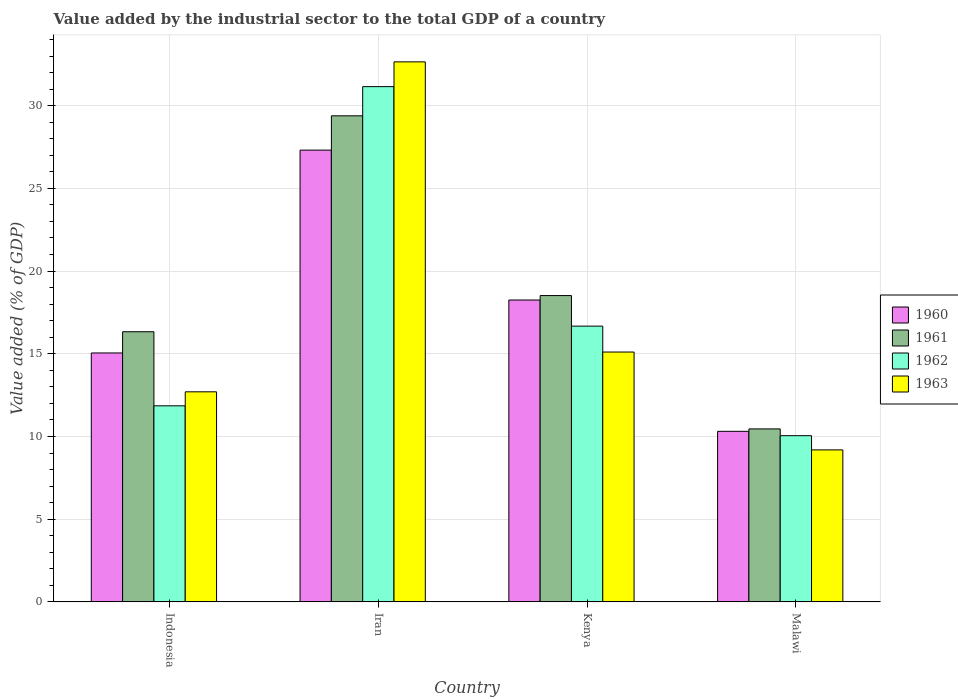Are the number of bars per tick equal to the number of legend labels?
Your response must be concise. Yes. Are the number of bars on each tick of the X-axis equal?
Your response must be concise. Yes. How many bars are there on the 2nd tick from the right?
Ensure brevity in your answer.  4. In how many cases, is the number of bars for a given country not equal to the number of legend labels?
Your answer should be very brief. 0. What is the value added by the industrial sector to the total GDP in 1960 in Indonesia?
Keep it short and to the point. 15.05. Across all countries, what is the maximum value added by the industrial sector to the total GDP in 1962?
Ensure brevity in your answer.  31.15. Across all countries, what is the minimum value added by the industrial sector to the total GDP in 1961?
Make the answer very short. 10.46. In which country was the value added by the industrial sector to the total GDP in 1962 maximum?
Give a very brief answer. Iran. In which country was the value added by the industrial sector to the total GDP in 1963 minimum?
Provide a succinct answer. Malawi. What is the total value added by the industrial sector to the total GDP in 1963 in the graph?
Give a very brief answer. 69.64. What is the difference between the value added by the industrial sector to the total GDP in 1963 in Iran and that in Malawi?
Give a very brief answer. 23.46. What is the difference between the value added by the industrial sector to the total GDP in 1962 in Kenya and the value added by the industrial sector to the total GDP in 1961 in Iran?
Offer a very short reply. -12.71. What is the average value added by the industrial sector to the total GDP in 1962 per country?
Your response must be concise. 17.43. What is the difference between the value added by the industrial sector to the total GDP of/in 1962 and value added by the industrial sector to the total GDP of/in 1960 in Iran?
Offer a very short reply. 3.84. In how many countries, is the value added by the industrial sector to the total GDP in 1960 greater than 8 %?
Make the answer very short. 4. What is the ratio of the value added by the industrial sector to the total GDP in 1961 in Iran to that in Malawi?
Offer a very short reply. 2.81. Is the difference between the value added by the industrial sector to the total GDP in 1962 in Kenya and Malawi greater than the difference between the value added by the industrial sector to the total GDP in 1960 in Kenya and Malawi?
Ensure brevity in your answer.  No. What is the difference between the highest and the second highest value added by the industrial sector to the total GDP in 1962?
Offer a very short reply. 4.82. What is the difference between the highest and the lowest value added by the industrial sector to the total GDP in 1961?
Give a very brief answer. 18.93. In how many countries, is the value added by the industrial sector to the total GDP in 1962 greater than the average value added by the industrial sector to the total GDP in 1962 taken over all countries?
Offer a terse response. 1. What does the 1st bar from the left in Iran represents?
Your answer should be compact. 1960. What does the 4th bar from the right in Indonesia represents?
Ensure brevity in your answer.  1960. Is it the case that in every country, the sum of the value added by the industrial sector to the total GDP in 1961 and value added by the industrial sector to the total GDP in 1962 is greater than the value added by the industrial sector to the total GDP in 1963?
Your answer should be very brief. Yes. How many bars are there?
Your response must be concise. 16. How many countries are there in the graph?
Provide a short and direct response. 4. Are the values on the major ticks of Y-axis written in scientific E-notation?
Offer a very short reply. No. Does the graph contain any zero values?
Offer a terse response. No. Where does the legend appear in the graph?
Offer a very short reply. Center right. How many legend labels are there?
Ensure brevity in your answer.  4. What is the title of the graph?
Your answer should be compact. Value added by the industrial sector to the total GDP of a country. Does "1981" appear as one of the legend labels in the graph?
Provide a short and direct response. No. What is the label or title of the Y-axis?
Your answer should be compact. Value added (% of GDP). What is the Value added (% of GDP) in 1960 in Indonesia?
Keep it short and to the point. 15.05. What is the Value added (% of GDP) in 1961 in Indonesia?
Give a very brief answer. 16.33. What is the Value added (% of GDP) of 1962 in Indonesia?
Your answer should be compact. 11.85. What is the Value added (% of GDP) in 1963 in Indonesia?
Keep it short and to the point. 12.7. What is the Value added (% of GDP) of 1960 in Iran?
Keep it short and to the point. 27.31. What is the Value added (% of GDP) in 1961 in Iran?
Ensure brevity in your answer.  29.38. What is the Value added (% of GDP) in 1962 in Iran?
Provide a succinct answer. 31.15. What is the Value added (% of GDP) of 1963 in Iran?
Keep it short and to the point. 32.65. What is the Value added (% of GDP) of 1960 in Kenya?
Offer a terse response. 18.25. What is the Value added (% of GDP) of 1961 in Kenya?
Make the answer very short. 18.52. What is the Value added (% of GDP) of 1962 in Kenya?
Your response must be concise. 16.67. What is the Value added (% of GDP) of 1963 in Kenya?
Provide a short and direct response. 15.1. What is the Value added (% of GDP) of 1960 in Malawi?
Offer a terse response. 10.31. What is the Value added (% of GDP) in 1961 in Malawi?
Make the answer very short. 10.46. What is the Value added (% of GDP) in 1962 in Malawi?
Provide a short and direct response. 10.05. What is the Value added (% of GDP) of 1963 in Malawi?
Provide a short and direct response. 9.19. Across all countries, what is the maximum Value added (% of GDP) in 1960?
Ensure brevity in your answer.  27.31. Across all countries, what is the maximum Value added (% of GDP) in 1961?
Your answer should be compact. 29.38. Across all countries, what is the maximum Value added (% of GDP) of 1962?
Give a very brief answer. 31.15. Across all countries, what is the maximum Value added (% of GDP) in 1963?
Make the answer very short. 32.65. Across all countries, what is the minimum Value added (% of GDP) of 1960?
Provide a succinct answer. 10.31. Across all countries, what is the minimum Value added (% of GDP) in 1961?
Make the answer very short. 10.46. Across all countries, what is the minimum Value added (% of GDP) of 1962?
Provide a succinct answer. 10.05. Across all countries, what is the minimum Value added (% of GDP) in 1963?
Keep it short and to the point. 9.19. What is the total Value added (% of GDP) of 1960 in the graph?
Ensure brevity in your answer.  70.92. What is the total Value added (% of GDP) of 1961 in the graph?
Your answer should be very brief. 74.69. What is the total Value added (% of GDP) in 1962 in the graph?
Your response must be concise. 69.72. What is the total Value added (% of GDP) of 1963 in the graph?
Offer a very short reply. 69.64. What is the difference between the Value added (% of GDP) in 1960 in Indonesia and that in Iran?
Keep it short and to the point. -12.26. What is the difference between the Value added (% of GDP) in 1961 in Indonesia and that in Iran?
Offer a terse response. -13.05. What is the difference between the Value added (% of GDP) of 1962 in Indonesia and that in Iran?
Ensure brevity in your answer.  -19.3. What is the difference between the Value added (% of GDP) of 1963 in Indonesia and that in Iran?
Ensure brevity in your answer.  -19.95. What is the difference between the Value added (% of GDP) in 1960 in Indonesia and that in Kenya?
Your answer should be compact. -3.2. What is the difference between the Value added (% of GDP) in 1961 in Indonesia and that in Kenya?
Your response must be concise. -2.19. What is the difference between the Value added (% of GDP) in 1962 in Indonesia and that in Kenya?
Your answer should be compact. -4.82. What is the difference between the Value added (% of GDP) in 1963 in Indonesia and that in Kenya?
Your answer should be compact. -2.4. What is the difference between the Value added (% of GDP) of 1960 in Indonesia and that in Malawi?
Offer a terse response. 4.74. What is the difference between the Value added (% of GDP) in 1961 in Indonesia and that in Malawi?
Make the answer very short. 5.87. What is the difference between the Value added (% of GDP) of 1962 in Indonesia and that in Malawi?
Your answer should be very brief. 1.8. What is the difference between the Value added (% of GDP) in 1963 in Indonesia and that in Malawi?
Your answer should be very brief. 3.51. What is the difference between the Value added (% of GDP) in 1960 in Iran and that in Kenya?
Keep it short and to the point. 9.06. What is the difference between the Value added (% of GDP) in 1961 in Iran and that in Kenya?
Provide a short and direct response. 10.87. What is the difference between the Value added (% of GDP) of 1962 in Iran and that in Kenya?
Give a very brief answer. 14.48. What is the difference between the Value added (% of GDP) of 1963 in Iran and that in Kenya?
Your answer should be very brief. 17.54. What is the difference between the Value added (% of GDP) in 1960 in Iran and that in Malawi?
Provide a short and direct response. 17. What is the difference between the Value added (% of GDP) of 1961 in Iran and that in Malawi?
Provide a succinct answer. 18.93. What is the difference between the Value added (% of GDP) in 1962 in Iran and that in Malawi?
Provide a succinct answer. 21.1. What is the difference between the Value added (% of GDP) of 1963 in Iran and that in Malawi?
Your answer should be very brief. 23.46. What is the difference between the Value added (% of GDP) in 1960 in Kenya and that in Malawi?
Provide a succinct answer. 7.94. What is the difference between the Value added (% of GDP) in 1961 in Kenya and that in Malawi?
Provide a succinct answer. 8.06. What is the difference between the Value added (% of GDP) of 1962 in Kenya and that in Malawi?
Offer a very short reply. 6.62. What is the difference between the Value added (% of GDP) of 1963 in Kenya and that in Malawi?
Offer a terse response. 5.92. What is the difference between the Value added (% of GDP) of 1960 in Indonesia and the Value added (% of GDP) of 1961 in Iran?
Your response must be concise. -14.34. What is the difference between the Value added (% of GDP) of 1960 in Indonesia and the Value added (% of GDP) of 1962 in Iran?
Ensure brevity in your answer.  -16.1. What is the difference between the Value added (% of GDP) in 1960 in Indonesia and the Value added (% of GDP) in 1963 in Iran?
Give a very brief answer. -17.6. What is the difference between the Value added (% of GDP) of 1961 in Indonesia and the Value added (% of GDP) of 1962 in Iran?
Make the answer very short. -14.82. What is the difference between the Value added (% of GDP) of 1961 in Indonesia and the Value added (% of GDP) of 1963 in Iran?
Your response must be concise. -16.32. What is the difference between the Value added (% of GDP) in 1962 in Indonesia and the Value added (% of GDP) in 1963 in Iran?
Make the answer very short. -20.79. What is the difference between the Value added (% of GDP) in 1960 in Indonesia and the Value added (% of GDP) in 1961 in Kenya?
Provide a short and direct response. -3.47. What is the difference between the Value added (% of GDP) in 1960 in Indonesia and the Value added (% of GDP) in 1962 in Kenya?
Provide a succinct answer. -1.62. What is the difference between the Value added (% of GDP) of 1960 in Indonesia and the Value added (% of GDP) of 1963 in Kenya?
Your answer should be very brief. -0.06. What is the difference between the Value added (% of GDP) of 1961 in Indonesia and the Value added (% of GDP) of 1962 in Kenya?
Provide a short and direct response. -0.34. What is the difference between the Value added (% of GDP) of 1961 in Indonesia and the Value added (% of GDP) of 1963 in Kenya?
Keep it short and to the point. 1.23. What is the difference between the Value added (% of GDP) of 1962 in Indonesia and the Value added (% of GDP) of 1963 in Kenya?
Your answer should be very brief. -3.25. What is the difference between the Value added (% of GDP) of 1960 in Indonesia and the Value added (% of GDP) of 1961 in Malawi?
Offer a terse response. 4.59. What is the difference between the Value added (% of GDP) in 1960 in Indonesia and the Value added (% of GDP) in 1962 in Malawi?
Give a very brief answer. 5. What is the difference between the Value added (% of GDP) in 1960 in Indonesia and the Value added (% of GDP) in 1963 in Malawi?
Your answer should be compact. 5.86. What is the difference between the Value added (% of GDP) of 1961 in Indonesia and the Value added (% of GDP) of 1962 in Malawi?
Offer a very short reply. 6.28. What is the difference between the Value added (% of GDP) of 1961 in Indonesia and the Value added (% of GDP) of 1963 in Malawi?
Offer a terse response. 7.14. What is the difference between the Value added (% of GDP) of 1962 in Indonesia and the Value added (% of GDP) of 1963 in Malawi?
Your answer should be compact. 2.66. What is the difference between the Value added (% of GDP) of 1960 in Iran and the Value added (% of GDP) of 1961 in Kenya?
Give a very brief answer. 8.79. What is the difference between the Value added (% of GDP) in 1960 in Iran and the Value added (% of GDP) in 1962 in Kenya?
Your answer should be compact. 10.64. What is the difference between the Value added (% of GDP) of 1960 in Iran and the Value added (% of GDP) of 1963 in Kenya?
Ensure brevity in your answer.  12.21. What is the difference between the Value added (% of GDP) in 1961 in Iran and the Value added (% of GDP) in 1962 in Kenya?
Give a very brief answer. 12.71. What is the difference between the Value added (% of GDP) of 1961 in Iran and the Value added (% of GDP) of 1963 in Kenya?
Provide a succinct answer. 14.28. What is the difference between the Value added (% of GDP) of 1962 in Iran and the Value added (% of GDP) of 1963 in Kenya?
Keep it short and to the point. 16.04. What is the difference between the Value added (% of GDP) of 1960 in Iran and the Value added (% of GDP) of 1961 in Malawi?
Your answer should be compact. 16.86. What is the difference between the Value added (% of GDP) of 1960 in Iran and the Value added (% of GDP) of 1962 in Malawi?
Make the answer very short. 17.26. What is the difference between the Value added (% of GDP) in 1960 in Iran and the Value added (% of GDP) in 1963 in Malawi?
Your answer should be compact. 18.12. What is the difference between the Value added (% of GDP) of 1961 in Iran and the Value added (% of GDP) of 1962 in Malawi?
Offer a very short reply. 19.34. What is the difference between the Value added (% of GDP) of 1961 in Iran and the Value added (% of GDP) of 1963 in Malawi?
Give a very brief answer. 20.2. What is the difference between the Value added (% of GDP) in 1962 in Iran and the Value added (% of GDP) in 1963 in Malawi?
Your answer should be very brief. 21.96. What is the difference between the Value added (% of GDP) of 1960 in Kenya and the Value added (% of GDP) of 1961 in Malawi?
Keep it short and to the point. 7.79. What is the difference between the Value added (% of GDP) of 1960 in Kenya and the Value added (% of GDP) of 1962 in Malawi?
Provide a short and direct response. 8.2. What is the difference between the Value added (% of GDP) in 1960 in Kenya and the Value added (% of GDP) in 1963 in Malawi?
Your response must be concise. 9.06. What is the difference between the Value added (% of GDP) in 1961 in Kenya and the Value added (% of GDP) in 1962 in Malawi?
Provide a succinct answer. 8.47. What is the difference between the Value added (% of GDP) in 1961 in Kenya and the Value added (% of GDP) in 1963 in Malawi?
Your answer should be compact. 9.33. What is the difference between the Value added (% of GDP) in 1962 in Kenya and the Value added (% of GDP) in 1963 in Malawi?
Keep it short and to the point. 7.48. What is the average Value added (% of GDP) of 1960 per country?
Your response must be concise. 17.73. What is the average Value added (% of GDP) in 1961 per country?
Ensure brevity in your answer.  18.67. What is the average Value added (% of GDP) of 1962 per country?
Keep it short and to the point. 17.43. What is the average Value added (% of GDP) in 1963 per country?
Give a very brief answer. 17.41. What is the difference between the Value added (% of GDP) in 1960 and Value added (% of GDP) in 1961 in Indonesia?
Offer a very short reply. -1.28. What is the difference between the Value added (% of GDP) of 1960 and Value added (% of GDP) of 1962 in Indonesia?
Provide a succinct answer. 3.2. What is the difference between the Value added (% of GDP) in 1960 and Value added (% of GDP) in 1963 in Indonesia?
Offer a terse response. 2.35. What is the difference between the Value added (% of GDP) of 1961 and Value added (% of GDP) of 1962 in Indonesia?
Give a very brief answer. 4.48. What is the difference between the Value added (% of GDP) of 1961 and Value added (% of GDP) of 1963 in Indonesia?
Give a very brief answer. 3.63. What is the difference between the Value added (% of GDP) of 1962 and Value added (% of GDP) of 1963 in Indonesia?
Make the answer very short. -0.85. What is the difference between the Value added (% of GDP) in 1960 and Value added (% of GDP) in 1961 in Iran?
Keep it short and to the point. -2.07. What is the difference between the Value added (% of GDP) in 1960 and Value added (% of GDP) in 1962 in Iran?
Ensure brevity in your answer.  -3.84. What is the difference between the Value added (% of GDP) in 1960 and Value added (% of GDP) in 1963 in Iran?
Your response must be concise. -5.33. What is the difference between the Value added (% of GDP) of 1961 and Value added (% of GDP) of 1962 in Iran?
Give a very brief answer. -1.76. What is the difference between the Value added (% of GDP) of 1961 and Value added (% of GDP) of 1963 in Iran?
Ensure brevity in your answer.  -3.26. What is the difference between the Value added (% of GDP) in 1962 and Value added (% of GDP) in 1963 in Iran?
Your response must be concise. -1.5. What is the difference between the Value added (% of GDP) of 1960 and Value added (% of GDP) of 1961 in Kenya?
Your response must be concise. -0.27. What is the difference between the Value added (% of GDP) of 1960 and Value added (% of GDP) of 1962 in Kenya?
Provide a succinct answer. 1.58. What is the difference between the Value added (% of GDP) in 1960 and Value added (% of GDP) in 1963 in Kenya?
Offer a very short reply. 3.14. What is the difference between the Value added (% of GDP) of 1961 and Value added (% of GDP) of 1962 in Kenya?
Offer a very short reply. 1.85. What is the difference between the Value added (% of GDP) of 1961 and Value added (% of GDP) of 1963 in Kenya?
Give a very brief answer. 3.41. What is the difference between the Value added (% of GDP) in 1962 and Value added (% of GDP) in 1963 in Kenya?
Make the answer very short. 1.57. What is the difference between the Value added (% of GDP) in 1960 and Value added (% of GDP) in 1961 in Malawi?
Ensure brevity in your answer.  -0.15. What is the difference between the Value added (% of GDP) of 1960 and Value added (% of GDP) of 1962 in Malawi?
Give a very brief answer. 0.26. What is the difference between the Value added (% of GDP) of 1960 and Value added (% of GDP) of 1963 in Malawi?
Ensure brevity in your answer.  1.12. What is the difference between the Value added (% of GDP) of 1961 and Value added (% of GDP) of 1962 in Malawi?
Ensure brevity in your answer.  0.41. What is the difference between the Value added (% of GDP) of 1961 and Value added (% of GDP) of 1963 in Malawi?
Ensure brevity in your answer.  1.27. What is the difference between the Value added (% of GDP) of 1962 and Value added (% of GDP) of 1963 in Malawi?
Offer a very short reply. 0.86. What is the ratio of the Value added (% of GDP) of 1960 in Indonesia to that in Iran?
Keep it short and to the point. 0.55. What is the ratio of the Value added (% of GDP) of 1961 in Indonesia to that in Iran?
Your answer should be very brief. 0.56. What is the ratio of the Value added (% of GDP) of 1962 in Indonesia to that in Iran?
Keep it short and to the point. 0.38. What is the ratio of the Value added (% of GDP) in 1963 in Indonesia to that in Iran?
Give a very brief answer. 0.39. What is the ratio of the Value added (% of GDP) in 1960 in Indonesia to that in Kenya?
Offer a terse response. 0.82. What is the ratio of the Value added (% of GDP) in 1961 in Indonesia to that in Kenya?
Give a very brief answer. 0.88. What is the ratio of the Value added (% of GDP) of 1962 in Indonesia to that in Kenya?
Provide a short and direct response. 0.71. What is the ratio of the Value added (% of GDP) of 1963 in Indonesia to that in Kenya?
Make the answer very short. 0.84. What is the ratio of the Value added (% of GDP) in 1960 in Indonesia to that in Malawi?
Make the answer very short. 1.46. What is the ratio of the Value added (% of GDP) in 1961 in Indonesia to that in Malawi?
Your answer should be very brief. 1.56. What is the ratio of the Value added (% of GDP) in 1962 in Indonesia to that in Malawi?
Your answer should be very brief. 1.18. What is the ratio of the Value added (% of GDP) of 1963 in Indonesia to that in Malawi?
Provide a short and direct response. 1.38. What is the ratio of the Value added (% of GDP) in 1960 in Iran to that in Kenya?
Provide a short and direct response. 1.5. What is the ratio of the Value added (% of GDP) of 1961 in Iran to that in Kenya?
Ensure brevity in your answer.  1.59. What is the ratio of the Value added (% of GDP) of 1962 in Iran to that in Kenya?
Offer a terse response. 1.87. What is the ratio of the Value added (% of GDP) of 1963 in Iran to that in Kenya?
Ensure brevity in your answer.  2.16. What is the ratio of the Value added (% of GDP) of 1960 in Iran to that in Malawi?
Keep it short and to the point. 2.65. What is the ratio of the Value added (% of GDP) in 1961 in Iran to that in Malawi?
Make the answer very short. 2.81. What is the ratio of the Value added (% of GDP) in 1962 in Iran to that in Malawi?
Provide a short and direct response. 3.1. What is the ratio of the Value added (% of GDP) in 1963 in Iran to that in Malawi?
Ensure brevity in your answer.  3.55. What is the ratio of the Value added (% of GDP) in 1960 in Kenya to that in Malawi?
Provide a succinct answer. 1.77. What is the ratio of the Value added (% of GDP) of 1961 in Kenya to that in Malawi?
Your answer should be very brief. 1.77. What is the ratio of the Value added (% of GDP) in 1962 in Kenya to that in Malawi?
Ensure brevity in your answer.  1.66. What is the ratio of the Value added (% of GDP) in 1963 in Kenya to that in Malawi?
Give a very brief answer. 1.64. What is the difference between the highest and the second highest Value added (% of GDP) in 1960?
Your answer should be compact. 9.06. What is the difference between the highest and the second highest Value added (% of GDP) in 1961?
Provide a succinct answer. 10.87. What is the difference between the highest and the second highest Value added (% of GDP) of 1962?
Keep it short and to the point. 14.48. What is the difference between the highest and the second highest Value added (% of GDP) of 1963?
Offer a terse response. 17.54. What is the difference between the highest and the lowest Value added (% of GDP) in 1960?
Provide a succinct answer. 17. What is the difference between the highest and the lowest Value added (% of GDP) in 1961?
Give a very brief answer. 18.93. What is the difference between the highest and the lowest Value added (% of GDP) of 1962?
Ensure brevity in your answer.  21.1. What is the difference between the highest and the lowest Value added (% of GDP) in 1963?
Provide a short and direct response. 23.46. 